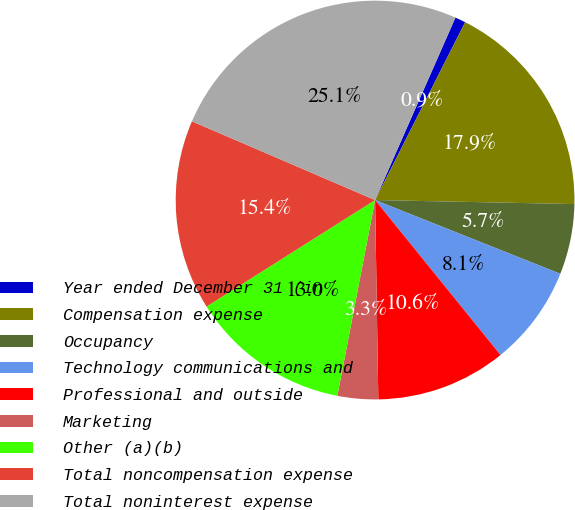Convert chart to OTSL. <chart><loc_0><loc_0><loc_500><loc_500><pie_chart><fcel>Year ended December 31 (in<fcel>Compensation expense<fcel>Occupancy<fcel>Technology communications and<fcel>Professional and outside<fcel>Marketing<fcel>Other (a)(b)<fcel>Total noncompensation expense<fcel>Total noninterest expense<nl><fcel>0.86%<fcel>17.86%<fcel>5.71%<fcel>8.14%<fcel>10.57%<fcel>3.29%<fcel>13.0%<fcel>15.43%<fcel>25.14%<nl></chart> 